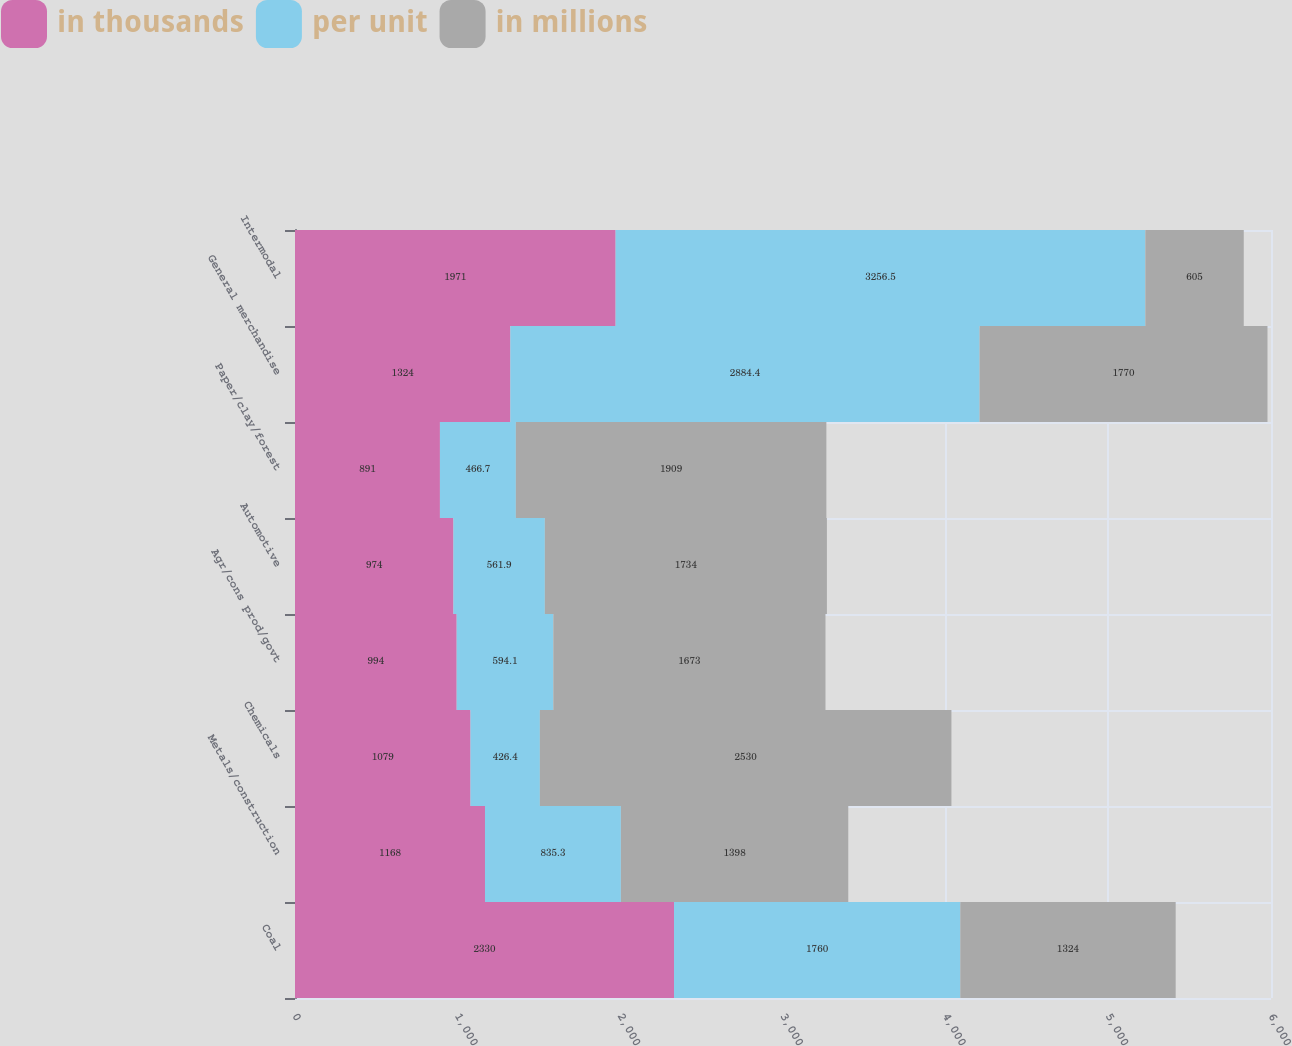<chart> <loc_0><loc_0><loc_500><loc_500><stacked_bar_chart><ecel><fcel>Coal<fcel>Metals/construction<fcel>Chemicals<fcel>Agr/cons prod/govt<fcel>Automotive<fcel>Paper/clay/forest<fcel>General merchandise<fcel>Intermodal<nl><fcel>in thousands<fcel>2330<fcel>1168<fcel>1079<fcel>994<fcel>974<fcel>891<fcel>1324<fcel>1971<nl><fcel>per unit<fcel>1760<fcel>835.3<fcel>426.4<fcel>594.1<fcel>561.9<fcel>466.7<fcel>2884.4<fcel>3256.5<nl><fcel>in millions<fcel>1324<fcel>1398<fcel>2530<fcel>1673<fcel>1734<fcel>1909<fcel>1770<fcel>605<nl></chart> 